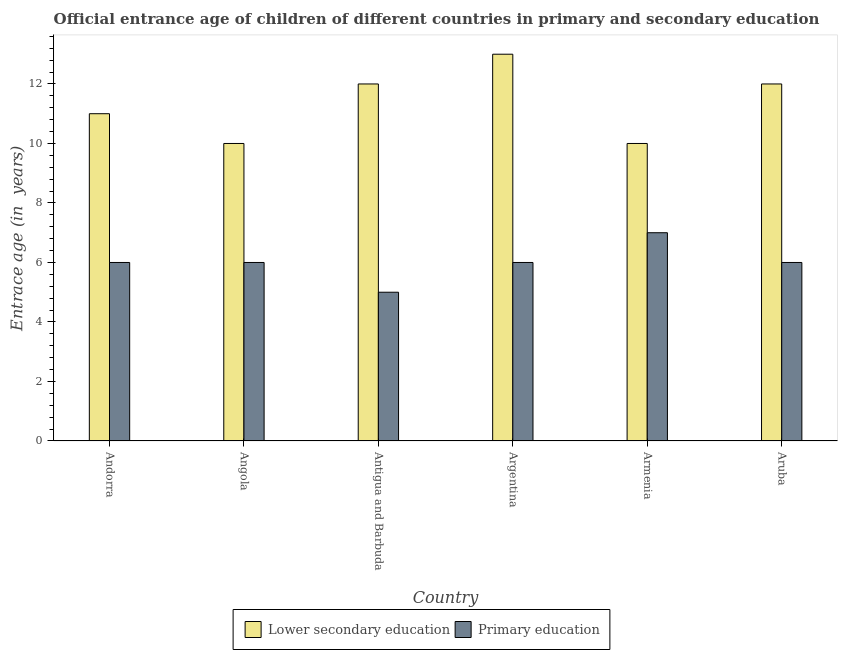How many groups of bars are there?
Your answer should be very brief. 6. Are the number of bars on each tick of the X-axis equal?
Offer a terse response. Yes. How many bars are there on the 2nd tick from the left?
Your response must be concise. 2. What is the label of the 5th group of bars from the left?
Offer a very short reply. Armenia. In how many cases, is the number of bars for a given country not equal to the number of legend labels?
Offer a terse response. 0. What is the entrance age of chiildren in primary education in Antigua and Barbuda?
Ensure brevity in your answer.  5. Across all countries, what is the maximum entrance age of chiildren in primary education?
Offer a terse response. 7. Across all countries, what is the minimum entrance age of chiildren in primary education?
Your response must be concise. 5. In which country was the entrance age of chiildren in primary education maximum?
Offer a very short reply. Armenia. In which country was the entrance age of chiildren in primary education minimum?
Your response must be concise. Antigua and Barbuda. What is the total entrance age of children in lower secondary education in the graph?
Make the answer very short. 68. What is the difference between the entrance age of children in lower secondary education in Andorra and that in Armenia?
Offer a terse response. 1. What is the difference between the entrance age of children in lower secondary education in Angola and the entrance age of chiildren in primary education in Argentina?
Your response must be concise. 4. What is the average entrance age of chiildren in primary education per country?
Offer a terse response. 6. What is the difference between the entrance age of chiildren in primary education and entrance age of children in lower secondary education in Antigua and Barbuda?
Offer a very short reply. -7. In how many countries, is the entrance age of chiildren in primary education greater than 8.8 years?
Keep it short and to the point. 0. Is the difference between the entrance age of children in lower secondary education in Argentina and Aruba greater than the difference between the entrance age of chiildren in primary education in Argentina and Aruba?
Ensure brevity in your answer.  Yes. What is the difference between the highest and the second highest entrance age of chiildren in primary education?
Give a very brief answer. 1. What is the difference between the highest and the lowest entrance age of children in lower secondary education?
Provide a succinct answer. 3. In how many countries, is the entrance age of children in lower secondary education greater than the average entrance age of children in lower secondary education taken over all countries?
Your response must be concise. 3. What does the 2nd bar from the left in Antigua and Barbuda represents?
Offer a terse response. Primary education. What does the 1st bar from the right in Antigua and Barbuda represents?
Keep it short and to the point. Primary education. How many bars are there?
Your response must be concise. 12. What is the difference between two consecutive major ticks on the Y-axis?
Make the answer very short. 2. Are the values on the major ticks of Y-axis written in scientific E-notation?
Make the answer very short. No. Does the graph contain grids?
Provide a short and direct response. No. How many legend labels are there?
Your response must be concise. 2. What is the title of the graph?
Your response must be concise. Official entrance age of children of different countries in primary and secondary education. What is the label or title of the X-axis?
Your response must be concise. Country. What is the label or title of the Y-axis?
Provide a short and direct response. Entrace age (in  years). What is the Entrace age (in  years) in Lower secondary education in Andorra?
Keep it short and to the point. 11. What is the Entrace age (in  years) of Primary education in Andorra?
Offer a very short reply. 6. What is the Entrace age (in  years) of Lower secondary education in Angola?
Offer a terse response. 10. What is the Entrace age (in  years) in Primary education in Angola?
Offer a very short reply. 6. What is the Entrace age (in  years) in Lower secondary education in Aruba?
Your answer should be very brief. 12. What is the Entrace age (in  years) of Primary education in Aruba?
Offer a terse response. 6. What is the total Entrace age (in  years) in Lower secondary education in the graph?
Your answer should be very brief. 68. What is the difference between the Entrace age (in  years) in Lower secondary education in Andorra and that in Angola?
Keep it short and to the point. 1. What is the difference between the Entrace age (in  years) of Primary education in Andorra and that in Antigua and Barbuda?
Your response must be concise. 1. What is the difference between the Entrace age (in  years) in Lower secondary education in Andorra and that in Argentina?
Give a very brief answer. -2. What is the difference between the Entrace age (in  years) in Primary education in Andorra and that in Armenia?
Your answer should be very brief. -1. What is the difference between the Entrace age (in  years) in Lower secondary education in Andorra and that in Aruba?
Provide a succinct answer. -1. What is the difference between the Entrace age (in  years) of Lower secondary education in Angola and that in Antigua and Barbuda?
Offer a very short reply. -2. What is the difference between the Entrace age (in  years) in Primary education in Angola and that in Antigua and Barbuda?
Offer a very short reply. 1. What is the difference between the Entrace age (in  years) of Lower secondary education in Angola and that in Argentina?
Provide a succinct answer. -3. What is the difference between the Entrace age (in  years) in Lower secondary education in Angola and that in Aruba?
Your answer should be compact. -2. What is the difference between the Entrace age (in  years) in Lower secondary education in Antigua and Barbuda and that in Argentina?
Provide a succinct answer. -1. What is the difference between the Entrace age (in  years) of Primary education in Antigua and Barbuda and that in Argentina?
Keep it short and to the point. -1. What is the difference between the Entrace age (in  years) of Lower secondary education in Antigua and Barbuda and that in Aruba?
Give a very brief answer. 0. What is the difference between the Entrace age (in  years) in Primary education in Argentina and that in Armenia?
Offer a very short reply. -1. What is the difference between the Entrace age (in  years) in Lower secondary education in Argentina and that in Aruba?
Keep it short and to the point. 1. What is the difference between the Entrace age (in  years) in Primary education in Argentina and that in Aruba?
Your response must be concise. 0. What is the difference between the Entrace age (in  years) of Primary education in Armenia and that in Aruba?
Offer a very short reply. 1. What is the difference between the Entrace age (in  years) of Lower secondary education in Andorra and the Entrace age (in  years) of Primary education in Antigua and Barbuda?
Ensure brevity in your answer.  6. What is the difference between the Entrace age (in  years) in Lower secondary education in Andorra and the Entrace age (in  years) in Primary education in Argentina?
Provide a short and direct response. 5. What is the difference between the Entrace age (in  years) in Lower secondary education in Andorra and the Entrace age (in  years) in Primary education in Aruba?
Your answer should be compact. 5. What is the difference between the Entrace age (in  years) in Lower secondary education in Angola and the Entrace age (in  years) in Primary education in Antigua and Barbuda?
Your response must be concise. 5. What is the difference between the Entrace age (in  years) in Lower secondary education in Angola and the Entrace age (in  years) in Primary education in Argentina?
Your answer should be compact. 4. What is the difference between the Entrace age (in  years) in Lower secondary education in Angola and the Entrace age (in  years) in Primary education in Armenia?
Offer a terse response. 3. What is the difference between the Entrace age (in  years) of Lower secondary education in Antigua and Barbuda and the Entrace age (in  years) of Primary education in Argentina?
Make the answer very short. 6. What is the difference between the Entrace age (in  years) of Lower secondary education in Argentina and the Entrace age (in  years) of Primary education in Armenia?
Your answer should be compact. 6. What is the difference between the Entrace age (in  years) of Lower secondary education in Argentina and the Entrace age (in  years) of Primary education in Aruba?
Your answer should be very brief. 7. What is the difference between the Entrace age (in  years) of Lower secondary education in Armenia and the Entrace age (in  years) of Primary education in Aruba?
Ensure brevity in your answer.  4. What is the average Entrace age (in  years) in Lower secondary education per country?
Make the answer very short. 11.33. What is the average Entrace age (in  years) of Primary education per country?
Your answer should be very brief. 6. What is the difference between the Entrace age (in  years) in Lower secondary education and Entrace age (in  years) in Primary education in Andorra?
Provide a short and direct response. 5. What is the difference between the Entrace age (in  years) in Lower secondary education and Entrace age (in  years) in Primary education in Antigua and Barbuda?
Ensure brevity in your answer.  7. What is the difference between the Entrace age (in  years) of Lower secondary education and Entrace age (in  years) of Primary education in Argentina?
Give a very brief answer. 7. What is the ratio of the Entrace age (in  years) in Lower secondary education in Andorra to that in Angola?
Ensure brevity in your answer.  1.1. What is the ratio of the Entrace age (in  years) in Primary education in Andorra to that in Angola?
Your response must be concise. 1. What is the ratio of the Entrace age (in  years) in Primary education in Andorra to that in Antigua and Barbuda?
Give a very brief answer. 1.2. What is the ratio of the Entrace age (in  years) of Lower secondary education in Andorra to that in Argentina?
Ensure brevity in your answer.  0.85. What is the ratio of the Entrace age (in  years) of Primary education in Andorra to that in Argentina?
Your response must be concise. 1. What is the ratio of the Entrace age (in  years) of Primary education in Andorra to that in Armenia?
Keep it short and to the point. 0.86. What is the ratio of the Entrace age (in  years) of Lower secondary education in Angola to that in Argentina?
Provide a succinct answer. 0.77. What is the ratio of the Entrace age (in  years) in Primary education in Angola to that in Argentina?
Provide a short and direct response. 1. What is the ratio of the Entrace age (in  years) in Lower secondary education in Angola to that in Armenia?
Keep it short and to the point. 1. What is the ratio of the Entrace age (in  years) in Lower secondary education in Angola to that in Aruba?
Offer a terse response. 0.83. What is the ratio of the Entrace age (in  years) in Primary education in Angola to that in Aruba?
Offer a very short reply. 1. What is the ratio of the Entrace age (in  years) in Primary education in Antigua and Barbuda to that in Armenia?
Offer a terse response. 0.71. What is the ratio of the Entrace age (in  years) in Lower secondary education in Antigua and Barbuda to that in Aruba?
Ensure brevity in your answer.  1. What is the ratio of the Entrace age (in  years) in Lower secondary education in Argentina to that in Armenia?
Offer a very short reply. 1.3. What is the ratio of the Entrace age (in  years) in Primary education in Argentina to that in Armenia?
Your response must be concise. 0.86. What is the ratio of the Entrace age (in  years) of Primary education in Armenia to that in Aruba?
Your answer should be very brief. 1.17. What is the difference between the highest and the second highest Entrace age (in  years) in Lower secondary education?
Ensure brevity in your answer.  1. What is the difference between the highest and the second highest Entrace age (in  years) of Primary education?
Offer a terse response. 1. What is the difference between the highest and the lowest Entrace age (in  years) in Primary education?
Offer a very short reply. 2. 